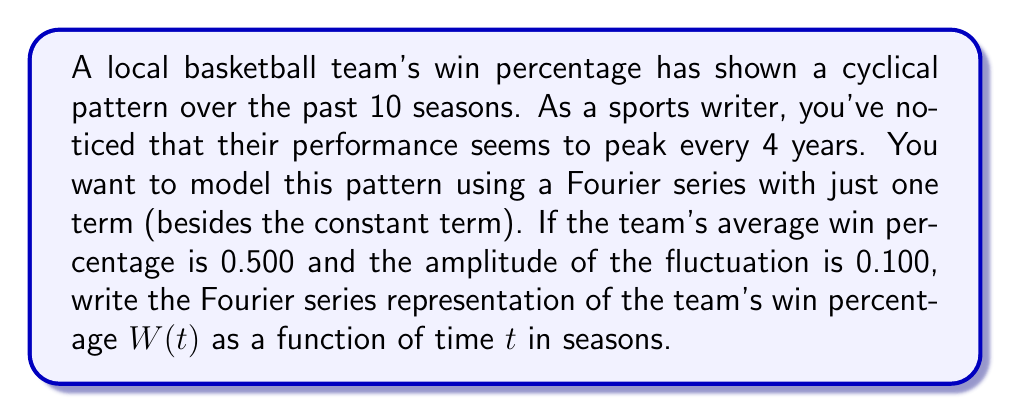Provide a solution to this math problem. Let's approach this step-by-step:

1) The general form of a Fourier series with one term (besides the constant term) is:

   $$ W(t) = a_0 + a_1 \cos(\omega t) + b_1 \sin(\omega t) $$

2) We're given that the average win percentage is 0.500, so $a_0 = 0.500$.

3) The period of the fluctuation is 4 seasons. In Fourier series, $\omega = \frac{2\pi}{T}$, where $T$ is the period. So:

   $$ \omega = \frac{2\pi}{4} = \frac{\pi}{2} $$

4) The amplitude of the fluctuation is 0.100. In a Fourier series with one term, the amplitude $A$ is related to $a_1$ and $b_1$ by:

   $$ A = \sqrt{a_1^2 + b_1^2} = 0.100 $$

5) To simplify, we can choose to use only the cosine term (setting $b_1 = 0$). This means $a_1 = 0.100$.

6) Putting this all together, we get:

   $$ W(t) = 0.500 + 0.100 \cos(\frac{\pi}{2}t) $$

This equation represents the team's win percentage as a function of time (in seasons), with peaks occurring every 4 seasons.
Answer: $$ W(t) = 0.500 + 0.100 \cos(\frac{\pi}{2}t) $$ 